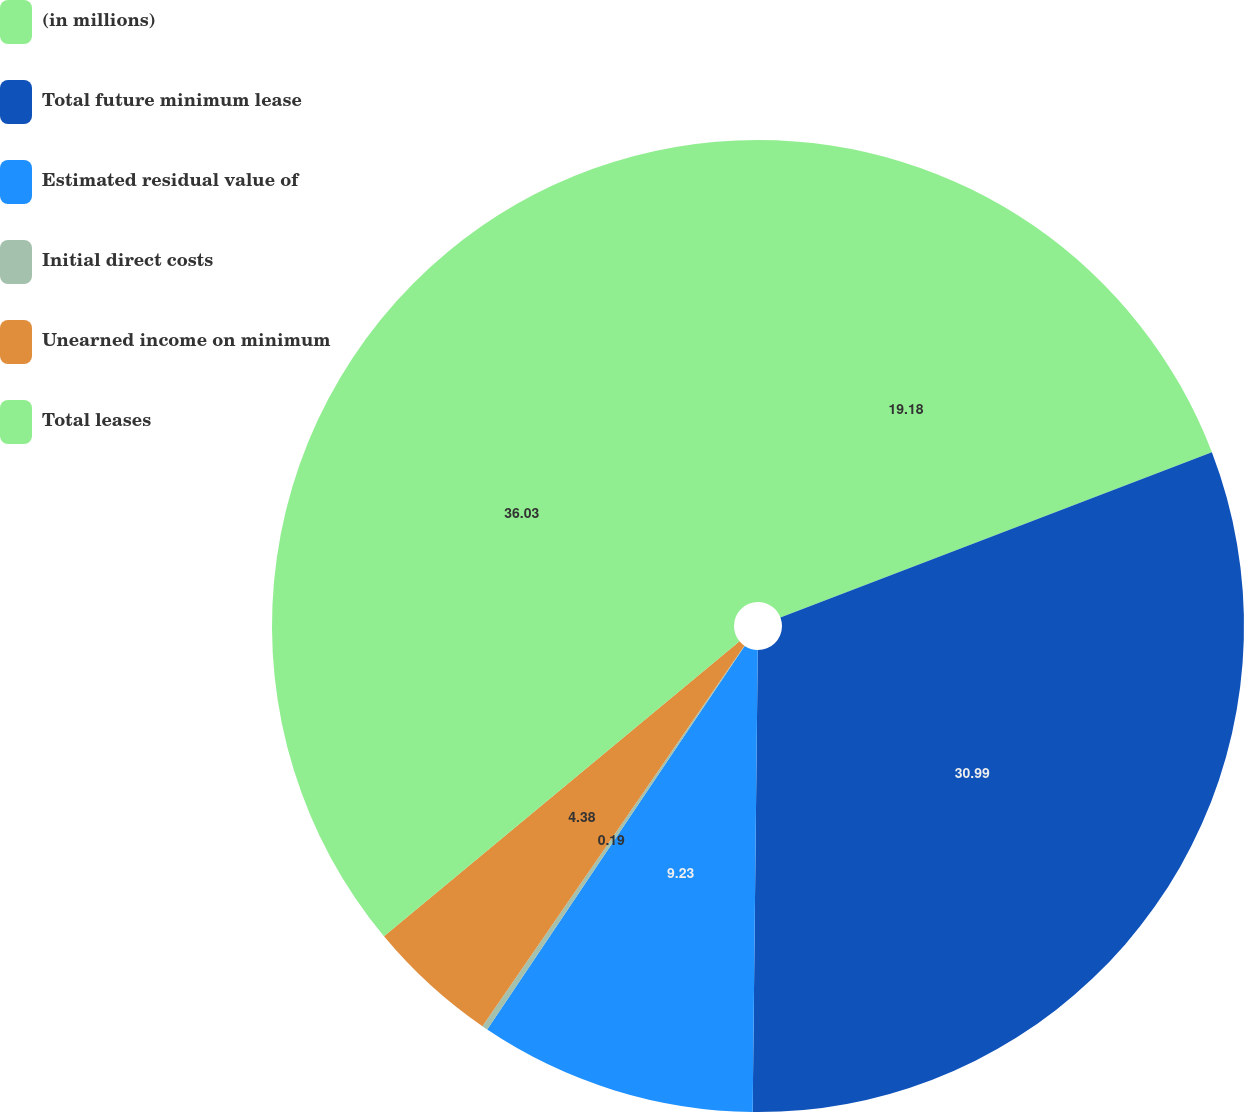<chart> <loc_0><loc_0><loc_500><loc_500><pie_chart><fcel>(in millions)<fcel>Total future minimum lease<fcel>Estimated residual value of<fcel>Initial direct costs<fcel>Unearned income on minimum<fcel>Total leases<nl><fcel>19.18%<fcel>30.99%<fcel>9.23%<fcel>0.19%<fcel>4.38%<fcel>36.02%<nl></chart> 